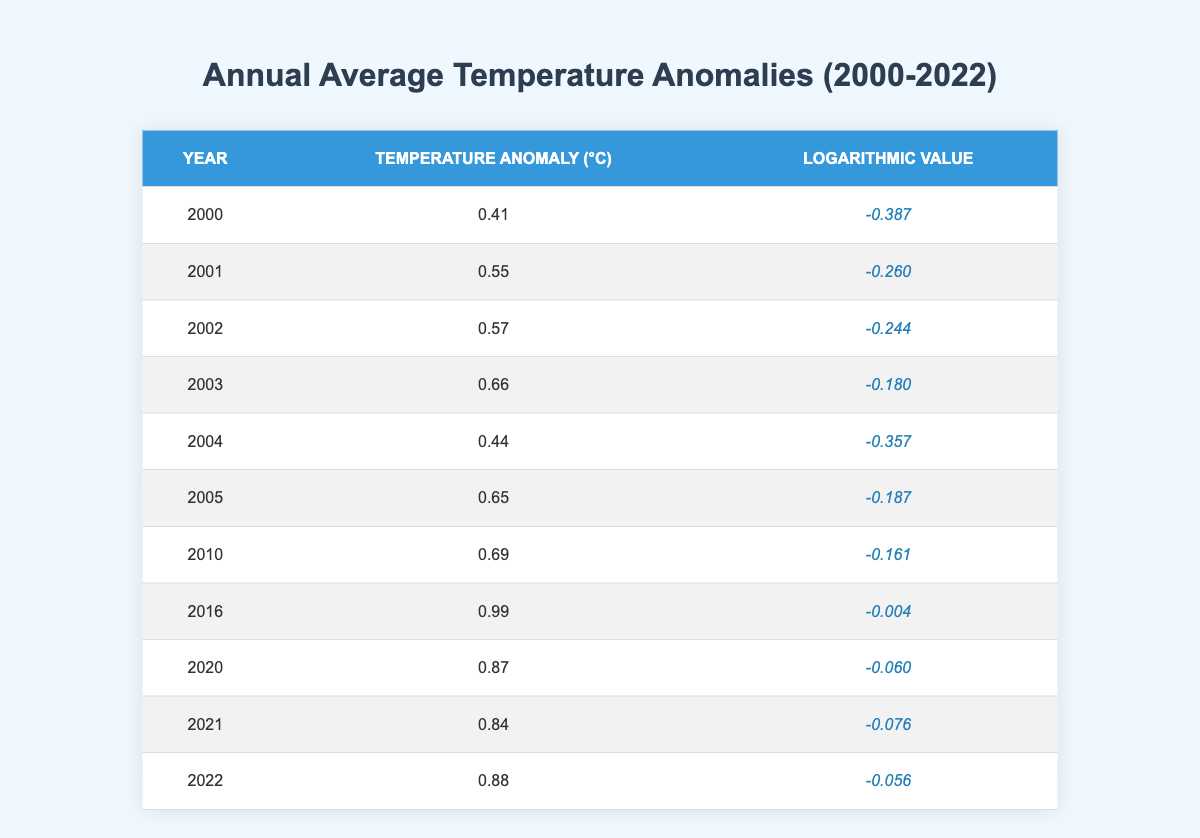What was the temperature anomaly in the year 2010? The table shows the data for the year 2010 in the second column, under the heading "Temperature Anomaly (°C)". According to the table, the value is 0.69.
Answer: 0.69 Which year had the highest temperature anomaly? By looking at the table, I find that the highest value under "Temperature Anomaly (°C)" is located next to the year 2016. Therefore, the year with the highest temperature anomaly is 2016 with a value of 0.99.
Answer: 2016 What is the temperature anomaly for the year 2004 and how does it compare to 2003? The temperature anomaly for the year 2004 is 0.44, while for 2003 it is 0.66. Comparing these two values, 0.66 (2003) is greater than 0.44 (2004), indicating a decrease.
Answer: Decrease What is the average temperature anomaly from 2000 to 2022? To find the average, I sum up all the temperature anomalies from 2000 to 2022, which gives (0.41 + 0.55 + 0.57 + 0.66 + 0.44 + 0.65 + 0.69 + 0.99 + 0.87 + 0.84 + 0.88) = 7.51. Since there are 11 data points in total, I then divide by 11 to find the average: 7.51 / 11 = approximately 0.682.
Answer: 0.682 Was the temperature anomaly greater in 2021 compared to 2020? The temperature anomaly for 2020 is 0.87, whereas for 2021 it is 0.84. Since 0.87 is greater than 0.84, the statement is false.
Answer: No How many years had a temperature anomaly greater than or equal to 0.80? By examining the table, I find that the years 2016 (0.99), 2020 (0.87), 2021 (0.84), and 2022 (0.88) each have a value greater than or equal to 0.80; this totals four years.
Answer: 4 Which year had the lowest temperature anomaly, and what was its value? I go through the table and find that the lowest temperature anomaly is 0.41 for the year 2000. Therefore, the answer is 2000 with a value of 0.41.
Answer: 2000, 0.41 What was the difference in temperature anomaly between the years 2002 and 2005? The anomaly for 2002 is 0.57, and for 2005 it is 0.65. Therefore, I subtract 0.57 from 0.65: 0.65 - 0.57 = 0.08.
Answer: 0.08 